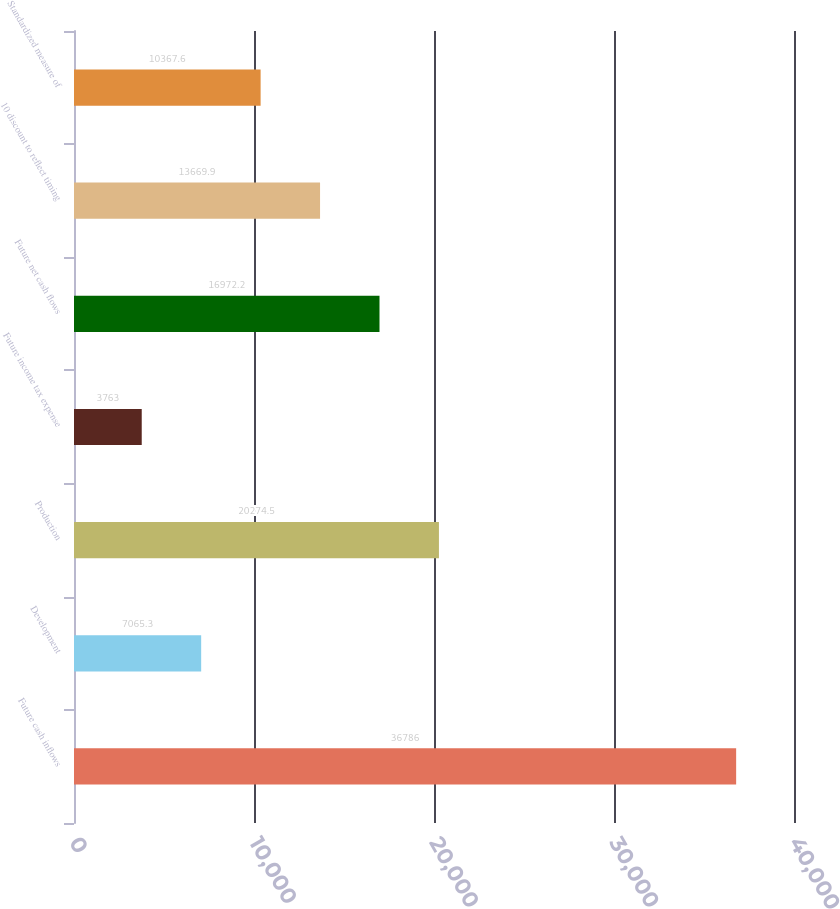Convert chart to OTSL. <chart><loc_0><loc_0><loc_500><loc_500><bar_chart><fcel>Future cash inflows<fcel>Development<fcel>Production<fcel>Future income tax expense<fcel>Future net cash flows<fcel>10 discount to reflect timing<fcel>Standardized measure of<nl><fcel>36786<fcel>7065.3<fcel>20274.5<fcel>3763<fcel>16972.2<fcel>13669.9<fcel>10367.6<nl></chart> 